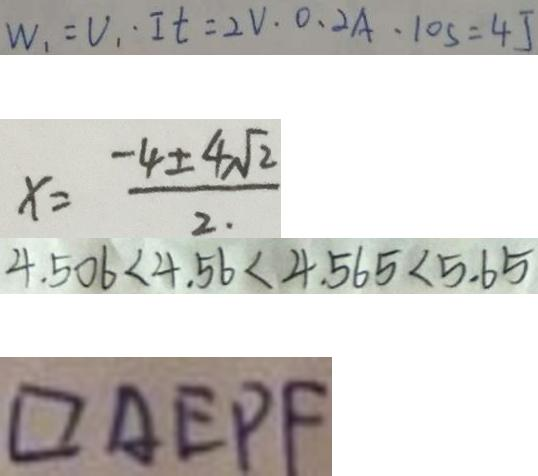<formula> <loc_0><loc_0><loc_500><loc_500>W _ { 1 } = V _ { 1 } \cdot I t = 2 V . 0 . 2 A \cdot 1 0 s = 4 J 
 x = \frac { - 4 \pm 4 \sqrt { 2 } } { 2 } 
 4 . 5 0 6 < 4 . 5 6 < 4 . 5 6 5 < 5 . 6 5 
 \square A E P F</formula> 